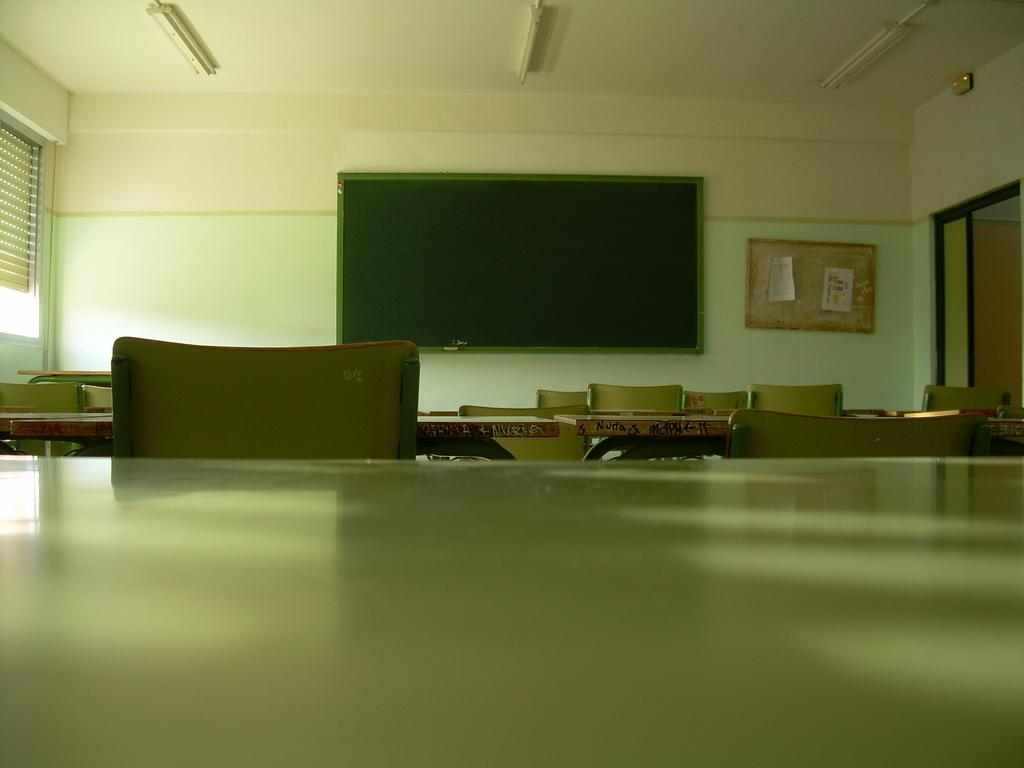What type of furniture is present in the image? There are tables and chairs in the image. What other objects can be seen in the image? There are boards and posters in the image. What is visible in the background of the image? There is a wall visible in the background of the image. How many cows are present in the image? There are no cows present in the image. What type of government is depicted in the posters in the image? The provided facts do not mention any specific government or political content in the posters, so it cannot be determined from the image. 